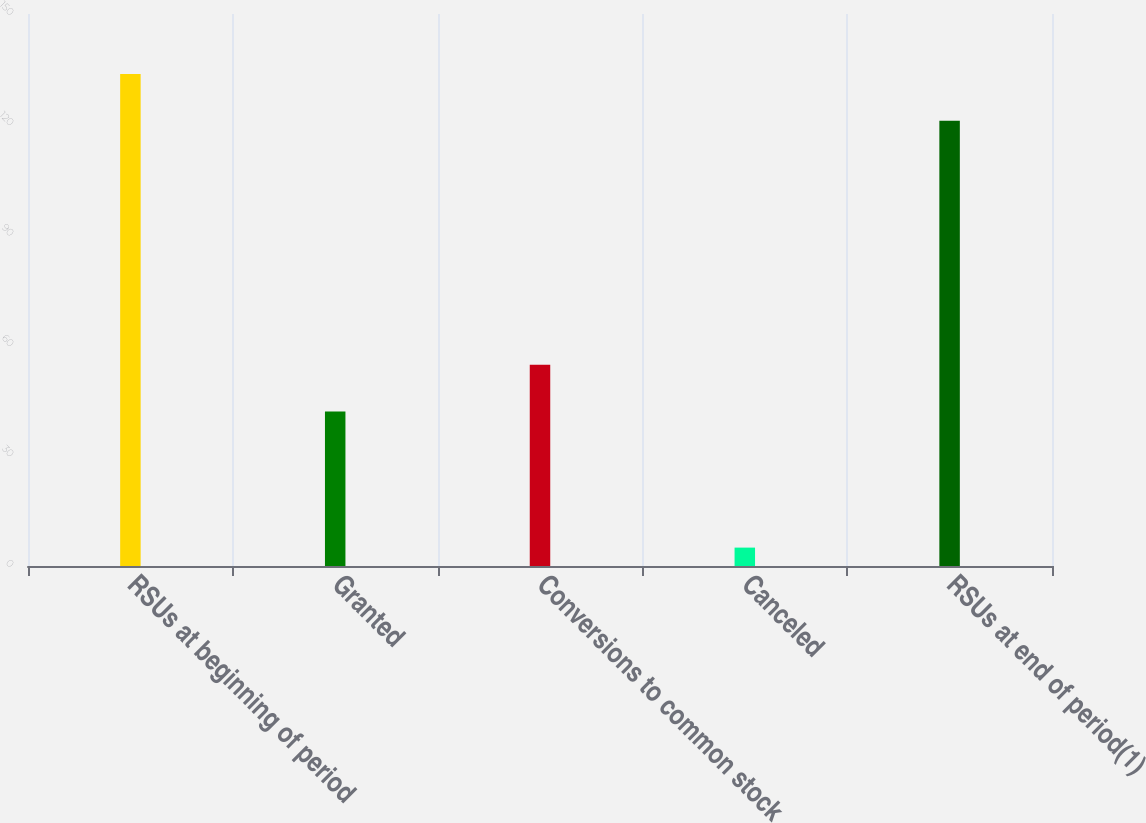Convert chart to OTSL. <chart><loc_0><loc_0><loc_500><loc_500><bar_chart><fcel>RSUs at beginning of period<fcel>Granted<fcel>Conversions to common stock<fcel>Canceled<fcel>RSUs at end of period(1)<nl><fcel>133.7<fcel>42<fcel>54.7<fcel>5<fcel>121<nl></chart> 